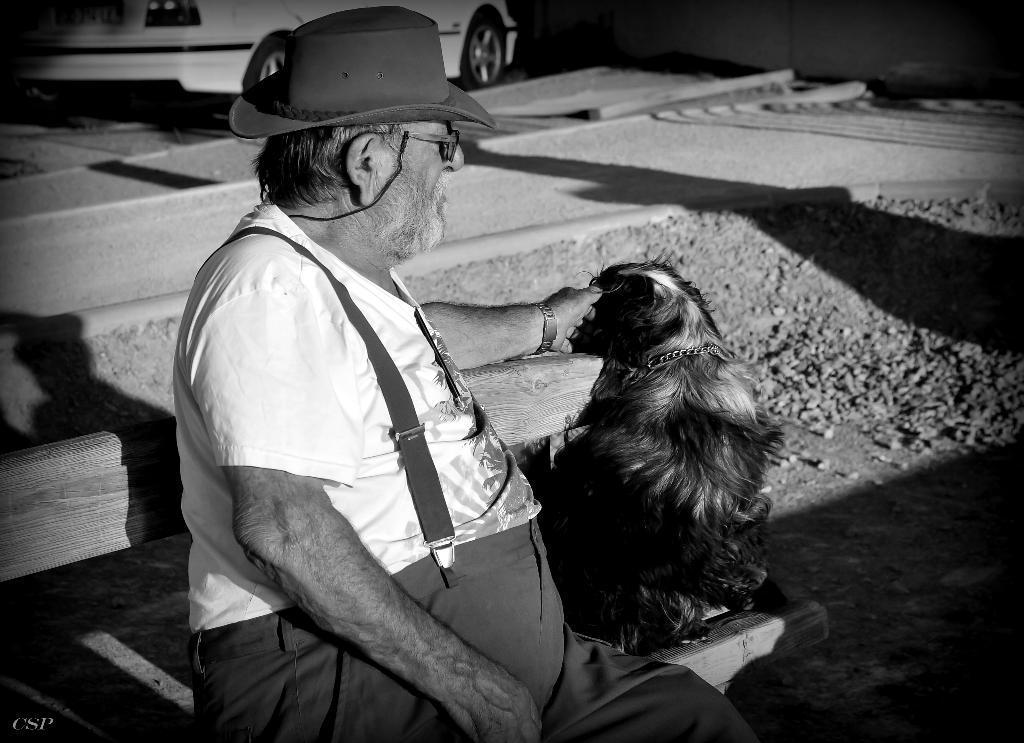Please provide a concise description of this image. It is a black and white photograph, here is a old man wearing a jumpsuit he is also wearing a hat , he is pampering the dog which is left side to him, the dog is of black color , beside the dog there are some rocks , in the background there is a car. 